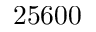<formula> <loc_0><loc_0><loc_500><loc_500>2 5 6 0 0</formula> 